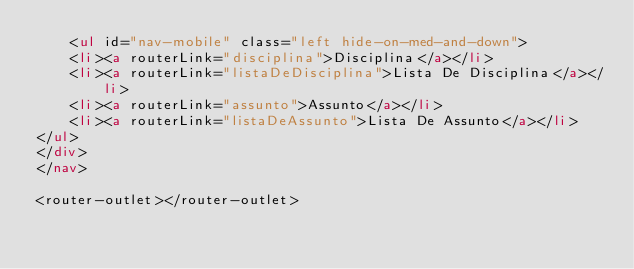Convert code to text. <code><loc_0><loc_0><loc_500><loc_500><_HTML_>    <ul id="nav-mobile" class="left hide-on-med-and-down">
    <li><a routerLink="disciplina">Disciplina</a></li>
    <li><a routerLink="listaDeDisciplina">Lista De Disciplina</a></li>
    <li><a routerLink="assunto">Assunto</a></li>
    <li><a routerLink="listaDeAssunto">Lista De Assunto</a></li>
</ul>
</div>
</nav>

<router-outlet></router-outlet></code> 